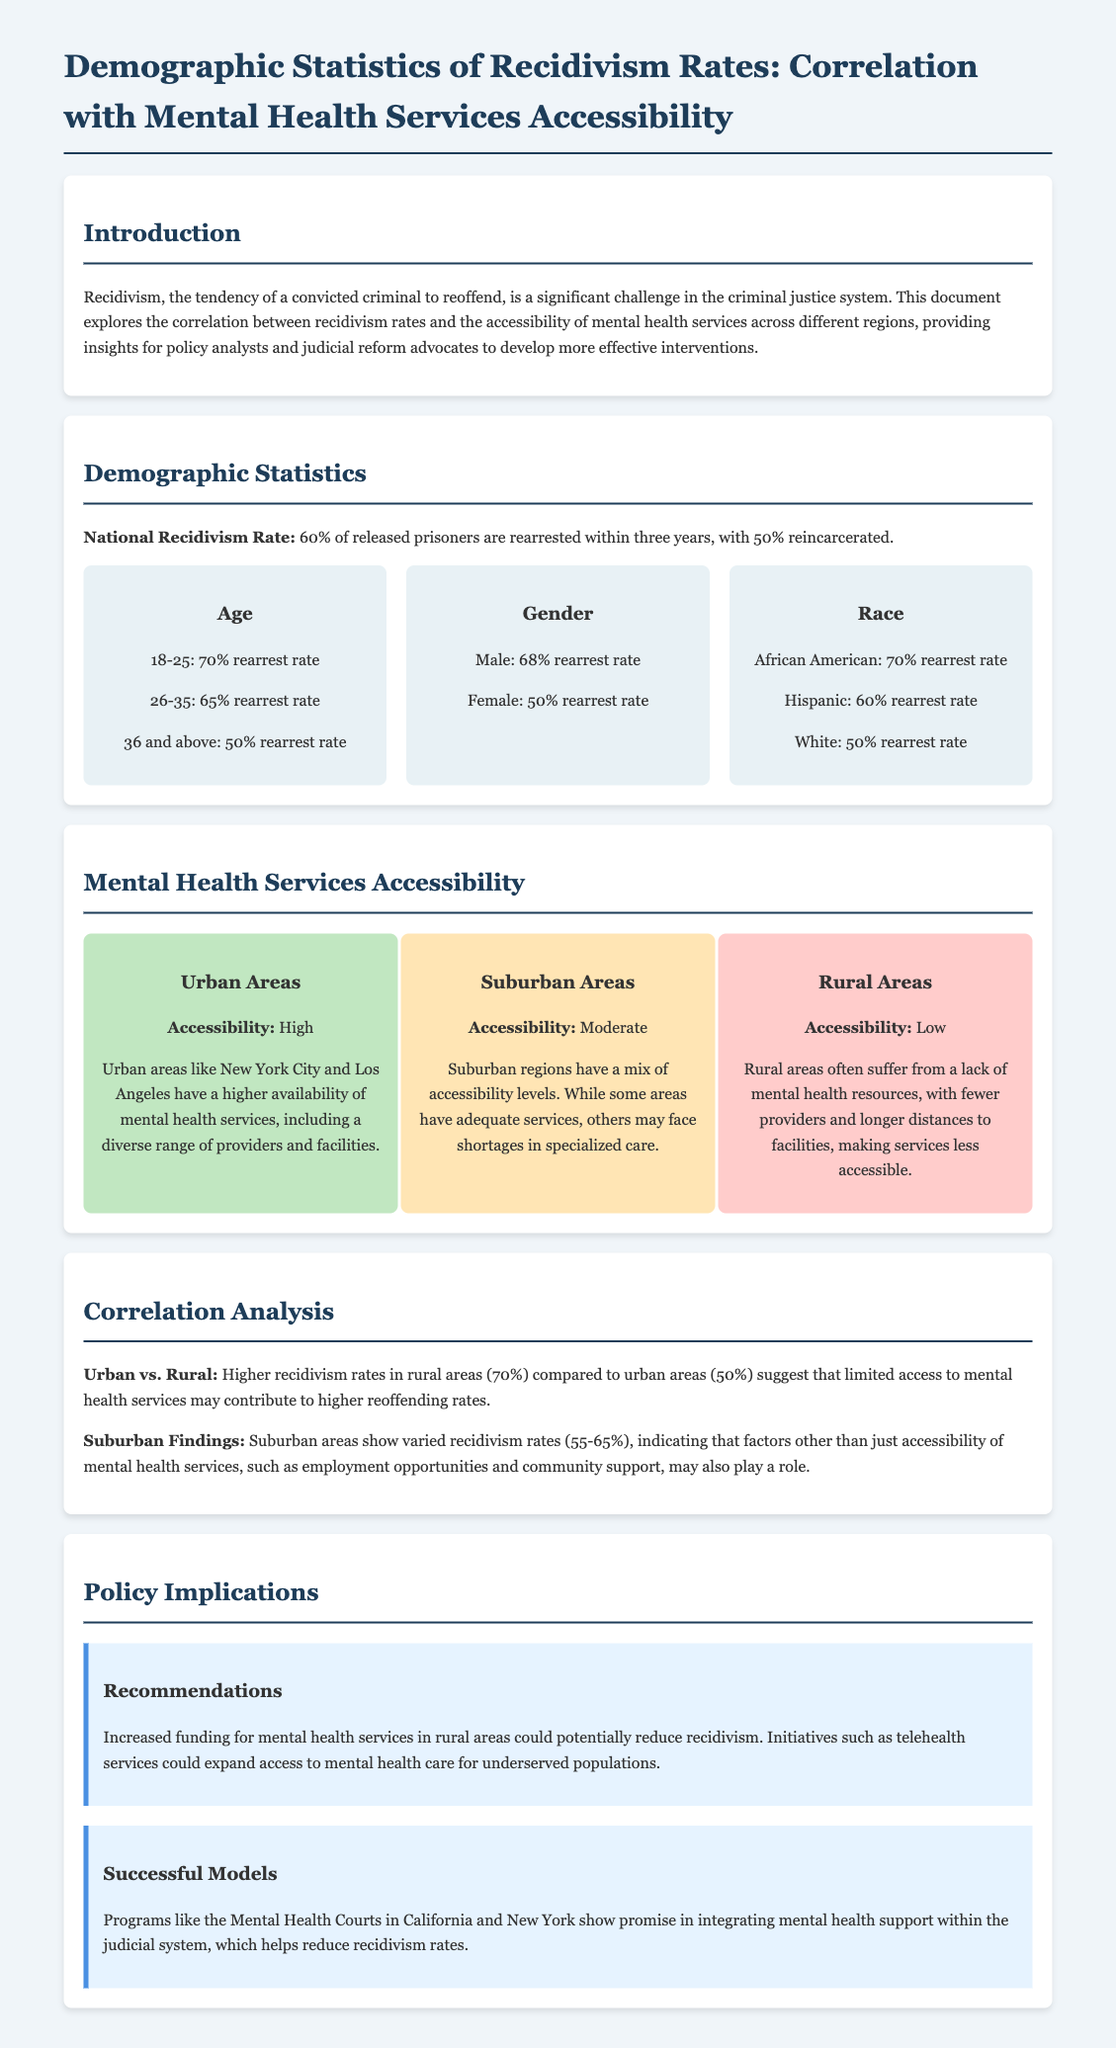What is the national recidivism rate? The document states that 60% of released prisoners are rearrested within three years.
Answer: 60% What is the rearrest rate for the 18-25 age group? In the demographic statistics section, it is mentioned that the rearrest rate for the 18-25 age group is 70%.
Answer: 70% Which area has a high accessibility of mental health services? The document indicates that urban areas like New York City and Los Angeles have high accessibility to mental health services.
Answer: Urban Areas What is the rearrest rate for African American individuals? According to the document, the rearrest rate for African American individuals is 70%.
Answer: 70% What correlation is observed between urban and rural recidivism rates? The document describes that there are higher recidivism rates in rural areas (70%) compared to urban areas (50%).
Answer: Higher in rural areas What does the document suggest for improving mental health services in rural areas? The recommendations indicate that increased funding for mental health services could potentially reduce recidivism in rural areas.
Answer: Increased funding What percentage of females are rearrested according to the gender statistics? The document states that the rearrest rate for females is 50%.
Answer: 50% What are Mental Health Courts examples of? They are cited in the document as successful models for integrating mental health support within the judicial system.
Answer: Successful Models What is mentioned as a reason for varying recidivism rates in suburban areas? The document highlights that factors other than just accessibility, such as employment opportunities and community support, may influence recidivism rates.
Answer: Other influencing factors 